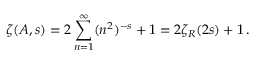<formula> <loc_0><loc_0><loc_500><loc_500>\zeta ( A , s ) = 2 \sum _ { n = 1 } ^ { \infty } ( n ^ { 2 } ) ^ { - s } + 1 = 2 \zeta _ { R } ( 2 s ) + 1 \, .</formula> 